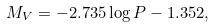<formula> <loc_0><loc_0><loc_500><loc_500>M _ { V } = - 2 . 7 3 5 \log P - 1 . 3 5 2 ,</formula> 